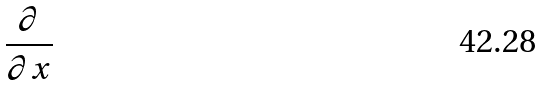Convert formula to latex. <formula><loc_0><loc_0><loc_500><loc_500>\frac { \partial } { \partial x }</formula> 